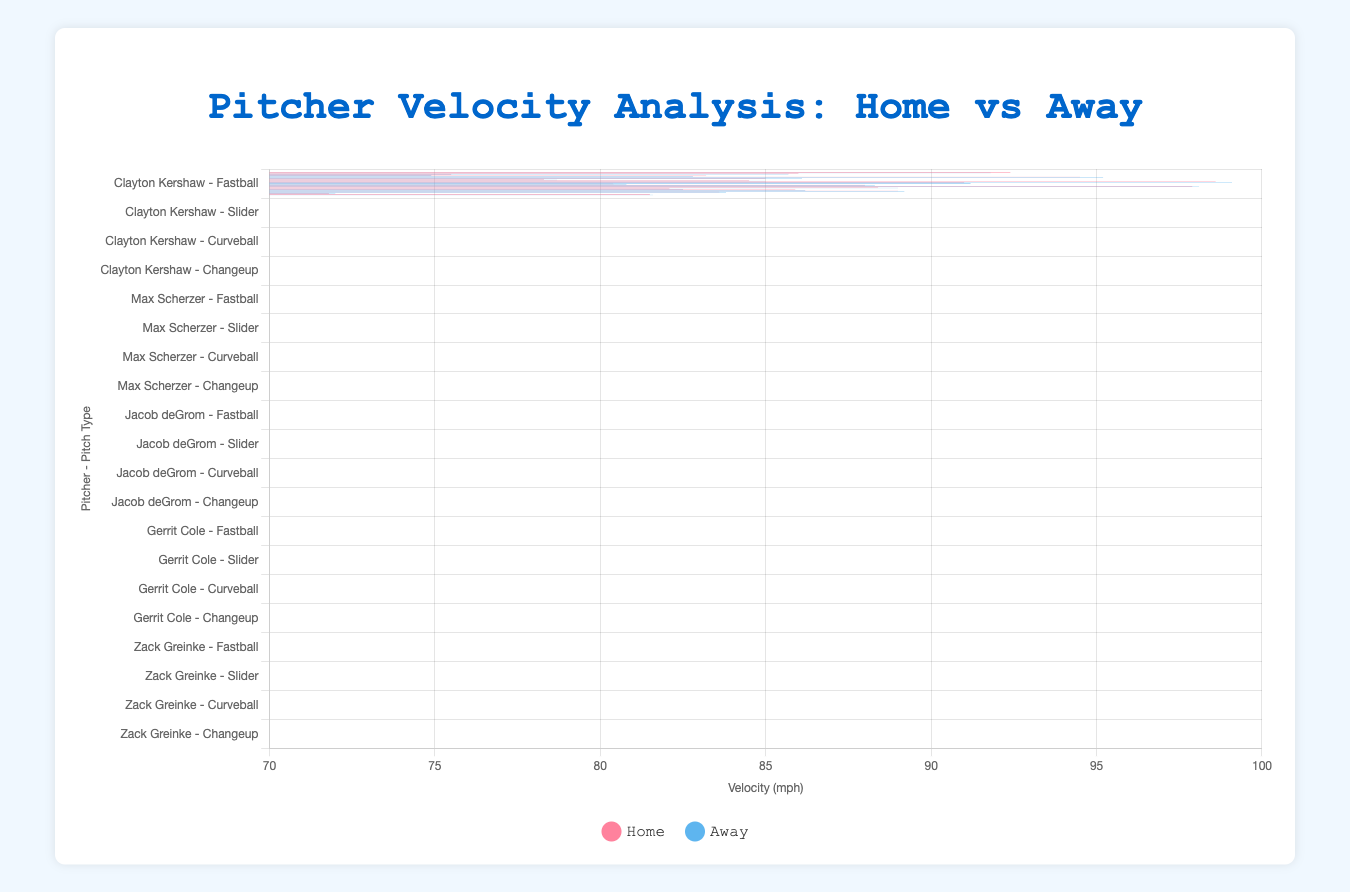Which pitcher has the highest average fastball velocity overall? To determine this, calculate the average of the home and away velocities for each pitcher and compare them. Jacob deGrom's average is (98.6 + 99.1) / 2 = 98.85 mph, which is higher than the others.
Answer: Jacob deGrom Does Max Scherzer throw his slider faster at home or away? Compare the slider velocities of Max Scherzer at home (85.0 mph) and away (86.1 mph). 86.1 mph is greater, so he throws faster away.
Answer: Away Which pitcher has the smallest difference in fastball velocity between home and away? Calculate the difference between home and away fastball velocities for each pitcher. Zack Greinke has the smallest difference:
Answer: Zack Greinke What is the average velocity of Gerrit Cole's pitches at home? To find this, sum the home velocities of all pitch types for Gerrit Cole and divide by the number of pitch types: (97.9 + 88.4 + 82.1 + 85.9) / 4 = 88.575 mph.
Answer: 88.575 mph Whose changeup has the highest home velocity? Compare the home changeup velocities among the pitchers, and Jacob deGrom has the highest at 88.0 mph.
Answer: Jacob deGrom Is there a pitcher whose fastball velocity is consistently higher away? Compare home and away fastball velocities for all pitchers; Max Scherzer and Jacob deGrom show higher away velocities.
Answer: Max Scherzer, Jacob deGrom Which pitch type shows the largest difference in velocity for Clayton Kershaw between home and away? Calculate the differences for each pitch type for Clayton Kershaw. The fastball shows the largest difference: 92.4 - 91.8 = 0.6 mph.
Answer: Fastball How does Zack Greinke's curveball velocity change from home to away? Compare the home (71.8 mph) and away (72.0 mph) velocities of his curveball. The value increases.
Answer: It increases slightly What is the combined average fastball velocity at home for all pitchers? Sum the home fastball velocities for all pitchers and divide by the number of pitchers: (92.4 + 94.5 + 98.6 + 97.9 + 89.0) / 5 = 94.48 mph.
Answer: 94.48 mph Which pitcher has the greatest difference in curveball velocity between home and away? Calculate the differences for each pitcher’s curveball velocities. Clayton Kershaw has the greatest difference: 75.5 - 74.9 = 0.6 mph.
Answer: Clayton Kershaw 